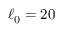Convert formula to latex. <formula><loc_0><loc_0><loc_500><loc_500>\ell _ { 0 } = 2 0</formula> 